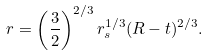Convert formula to latex. <formula><loc_0><loc_0><loc_500><loc_500>r = \left ( \frac { 3 } { 2 } \right ) ^ { 2 / 3 } r _ { s } ^ { 1 / 3 } ( R - t ) ^ { 2 / 3 } .</formula> 